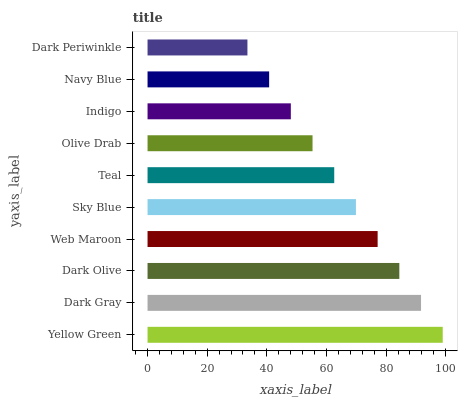Is Dark Periwinkle the minimum?
Answer yes or no. Yes. Is Yellow Green the maximum?
Answer yes or no. Yes. Is Dark Gray the minimum?
Answer yes or no. No. Is Dark Gray the maximum?
Answer yes or no. No. Is Yellow Green greater than Dark Gray?
Answer yes or no. Yes. Is Dark Gray less than Yellow Green?
Answer yes or no. Yes. Is Dark Gray greater than Yellow Green?
Answer yes or no. No. Is Yellow Green less than Dark Gray?
Answer yes or no. No. Is Sky Blue the high median?
Answer yes or no. Yes. Is Teal the low median?
Answer yes or no. Yes. Is Dark Gray the high median?
Answer yes or no. No. Is Dark Olive the low median?
Answer yes or no. No. 